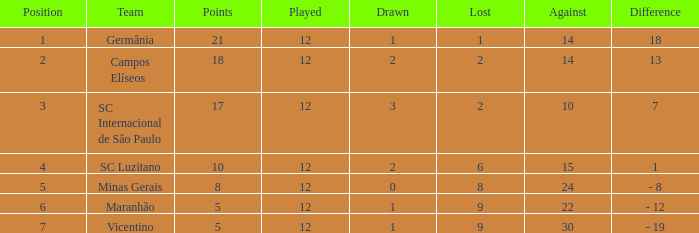What is the total of drawn games in which a player has played more than 12 times? 0.0. 